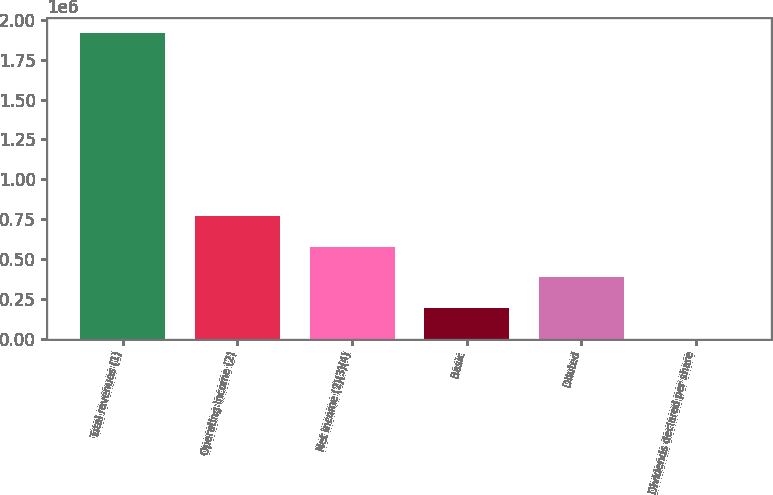Convert chart. <chart><loc_0><loc_0><loc_500><loc_500><bar_chart><fcel>Total revenues (1)<fcel>Operating income (2)<fcel>Net income (2)(3)(4)<fcel>Basic<fcel>Diluted<fcel>Dividends declared per share<nl><fcel>1.9178e+06<fcel>767118<fcel>575339<fcel>191780<fcel>383559<fcel>0.38<nl></chart> 